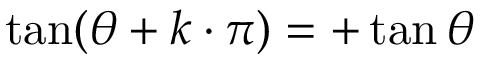<formula> <loc_0><loc_0><loc_500><loc_500>\tan ( \theta + k \cdot \pi ) = + \tan \theta</formula> 